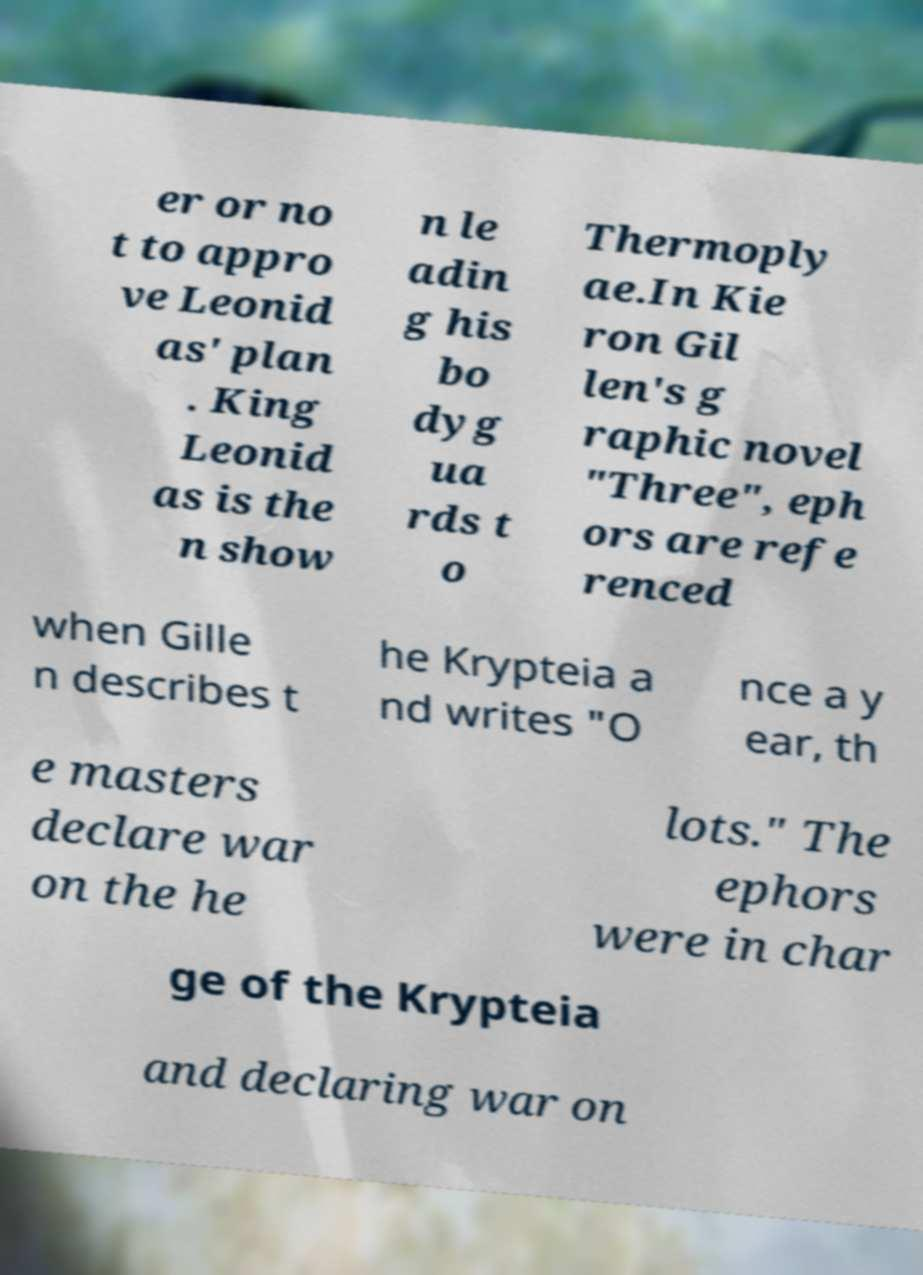Please identify and transcribe the text found in this image. er or no t to appro ve Leonid as' plan . King Leonid as is the n show n le adin g his bo dyg ua rds t o Thermoply ae.In Kie ron Gil len's g raphic novel "Three", eph ors are refe renced when Gille n describes t he Krypteia a nd writes "O nce a y ear, th e masters declare war on the he lots." The ephors were in char ge of the Krypteia and declaring war on 